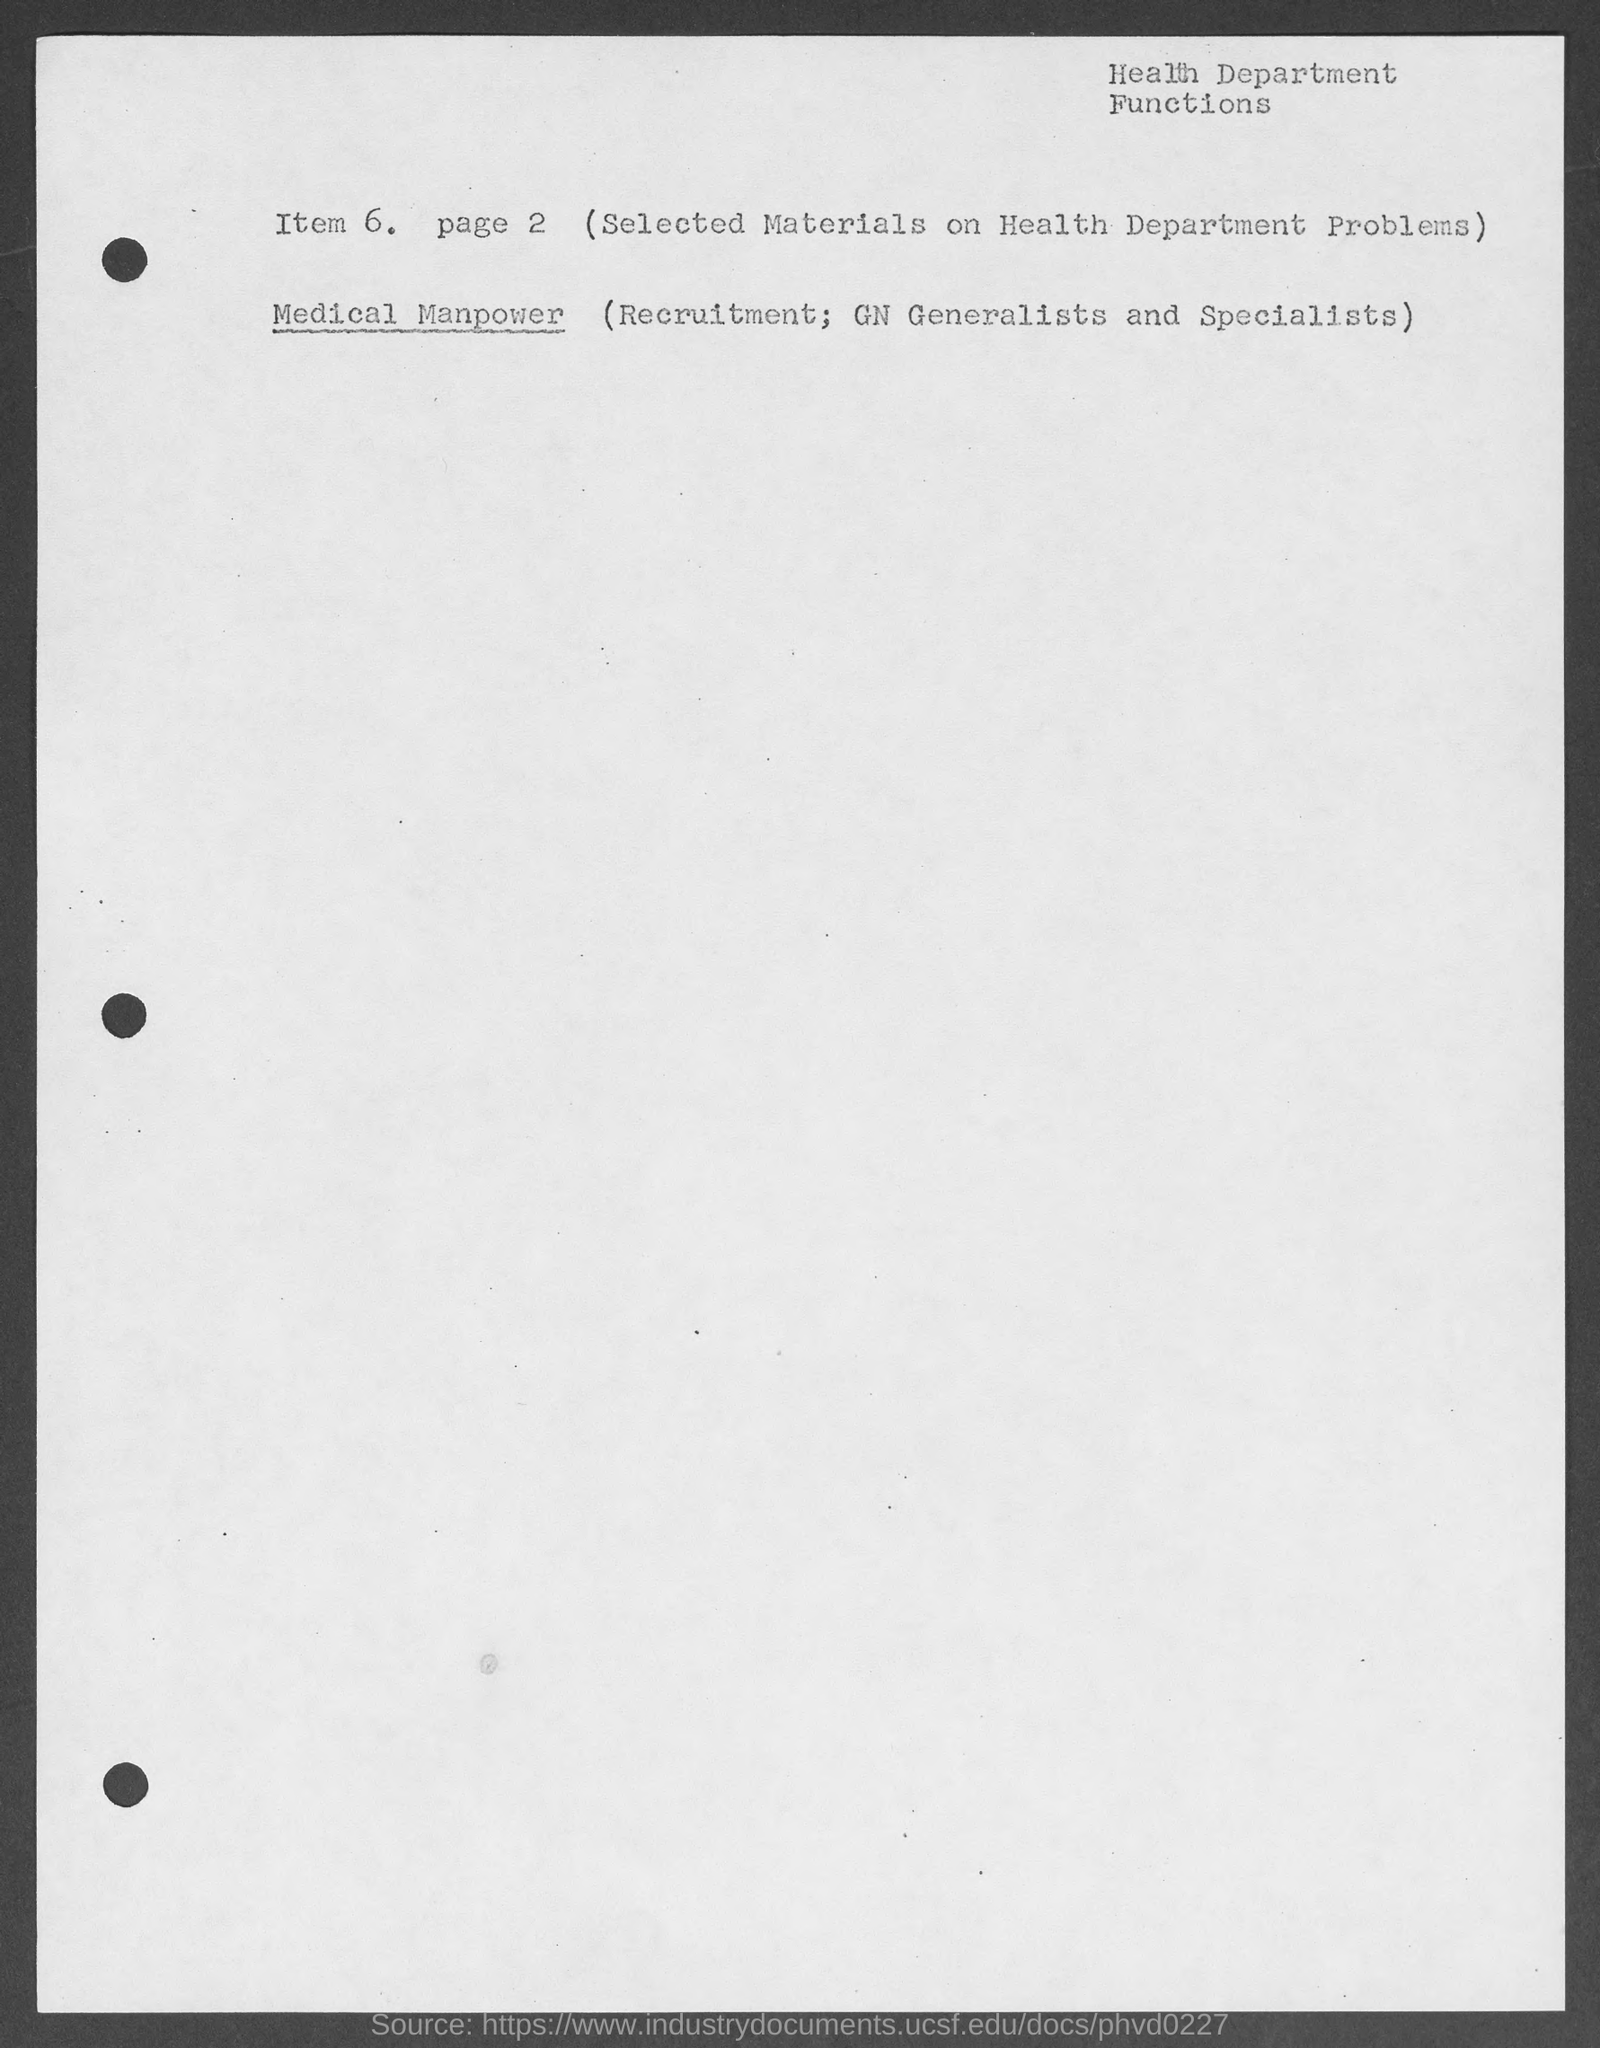Give some essential details in this illustration. The number of the page mentioned is 2.. The top-right corner of the document contains the text 'Health Department Functions.' 